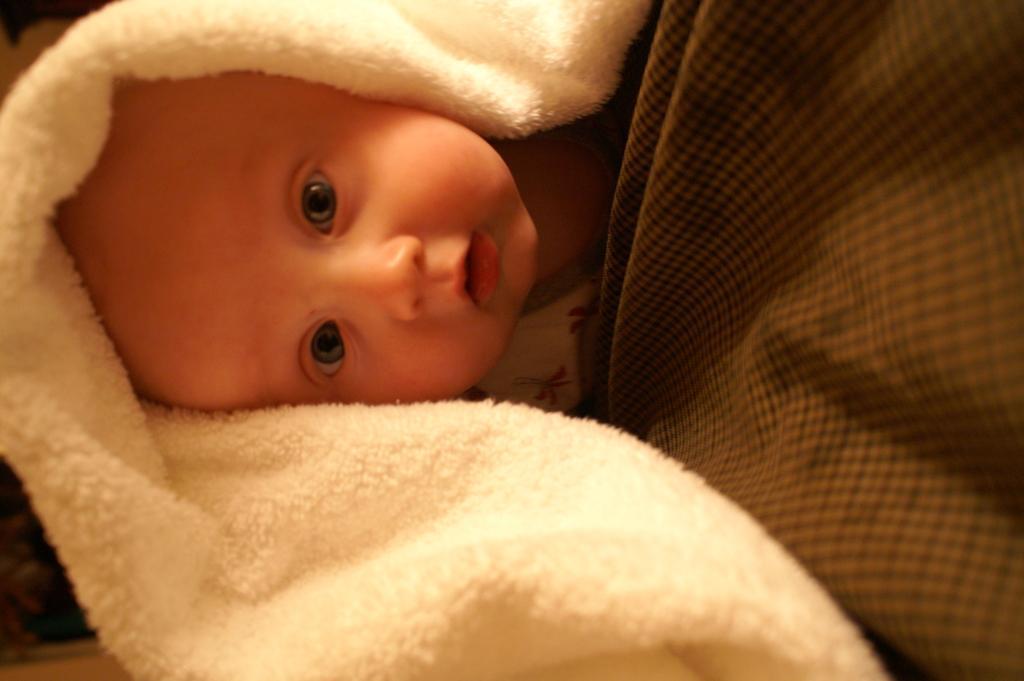Please provide a concise description of this image. In this picture we can see a kid, on the left side there is a tower, we can see a cloth on the right side. 